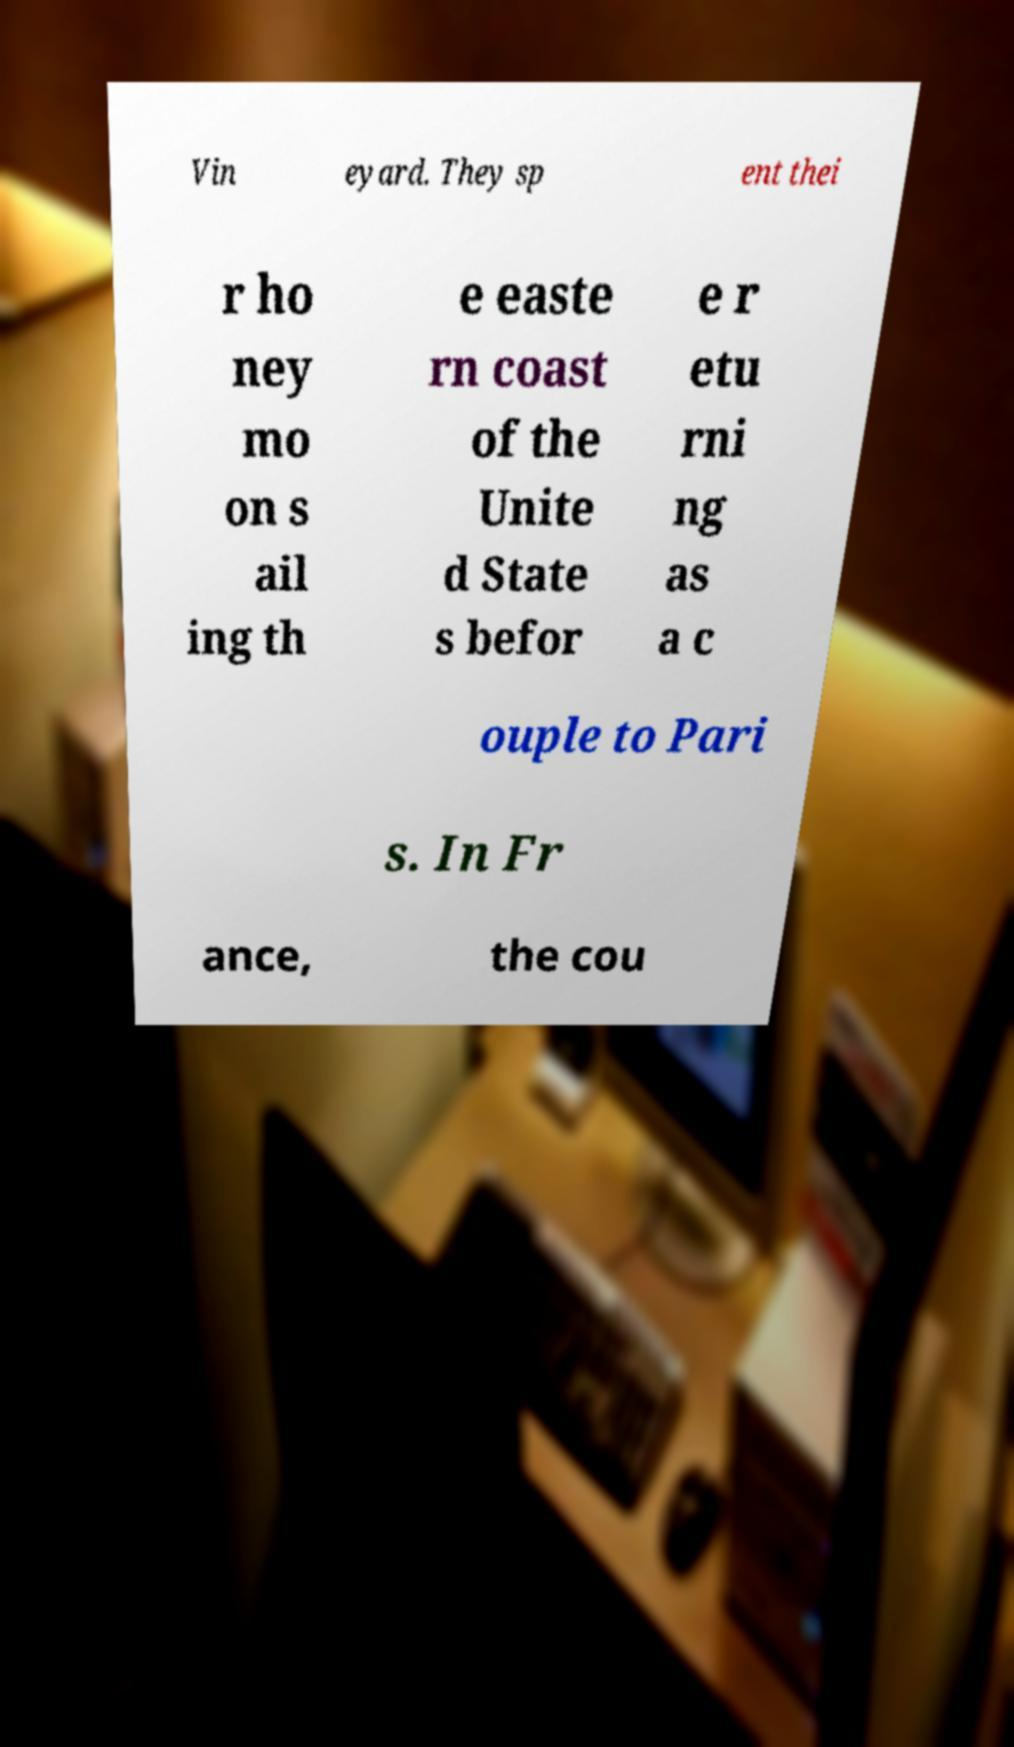Can you accurately transcribe the text from the provided image for me? Vin eyard. They sp ent thei r ho ney mo on s ail ing th e easte rn coast of the Unite d State s befor e r etu rni ng as a c ouple to Pari s. In Fr ance, the cou 